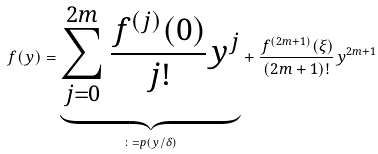<formula> <loc_0><loc_0><loc_500><loc_500>f ( y ) = \underset { \colon = p ( y / \delta ) } { \underbrace { \sum _ { j = 0 } ^ { 2 m } \frac { f ^ { ( j ) } ( 0 ) } { j ! } y ^ { j } } } + \frac { f ^ { ( 2 m + 1 ) } ( \xi ) } { ( 2 m + 1 ) ! } y ^ { 2 m + 1 }</formula> 